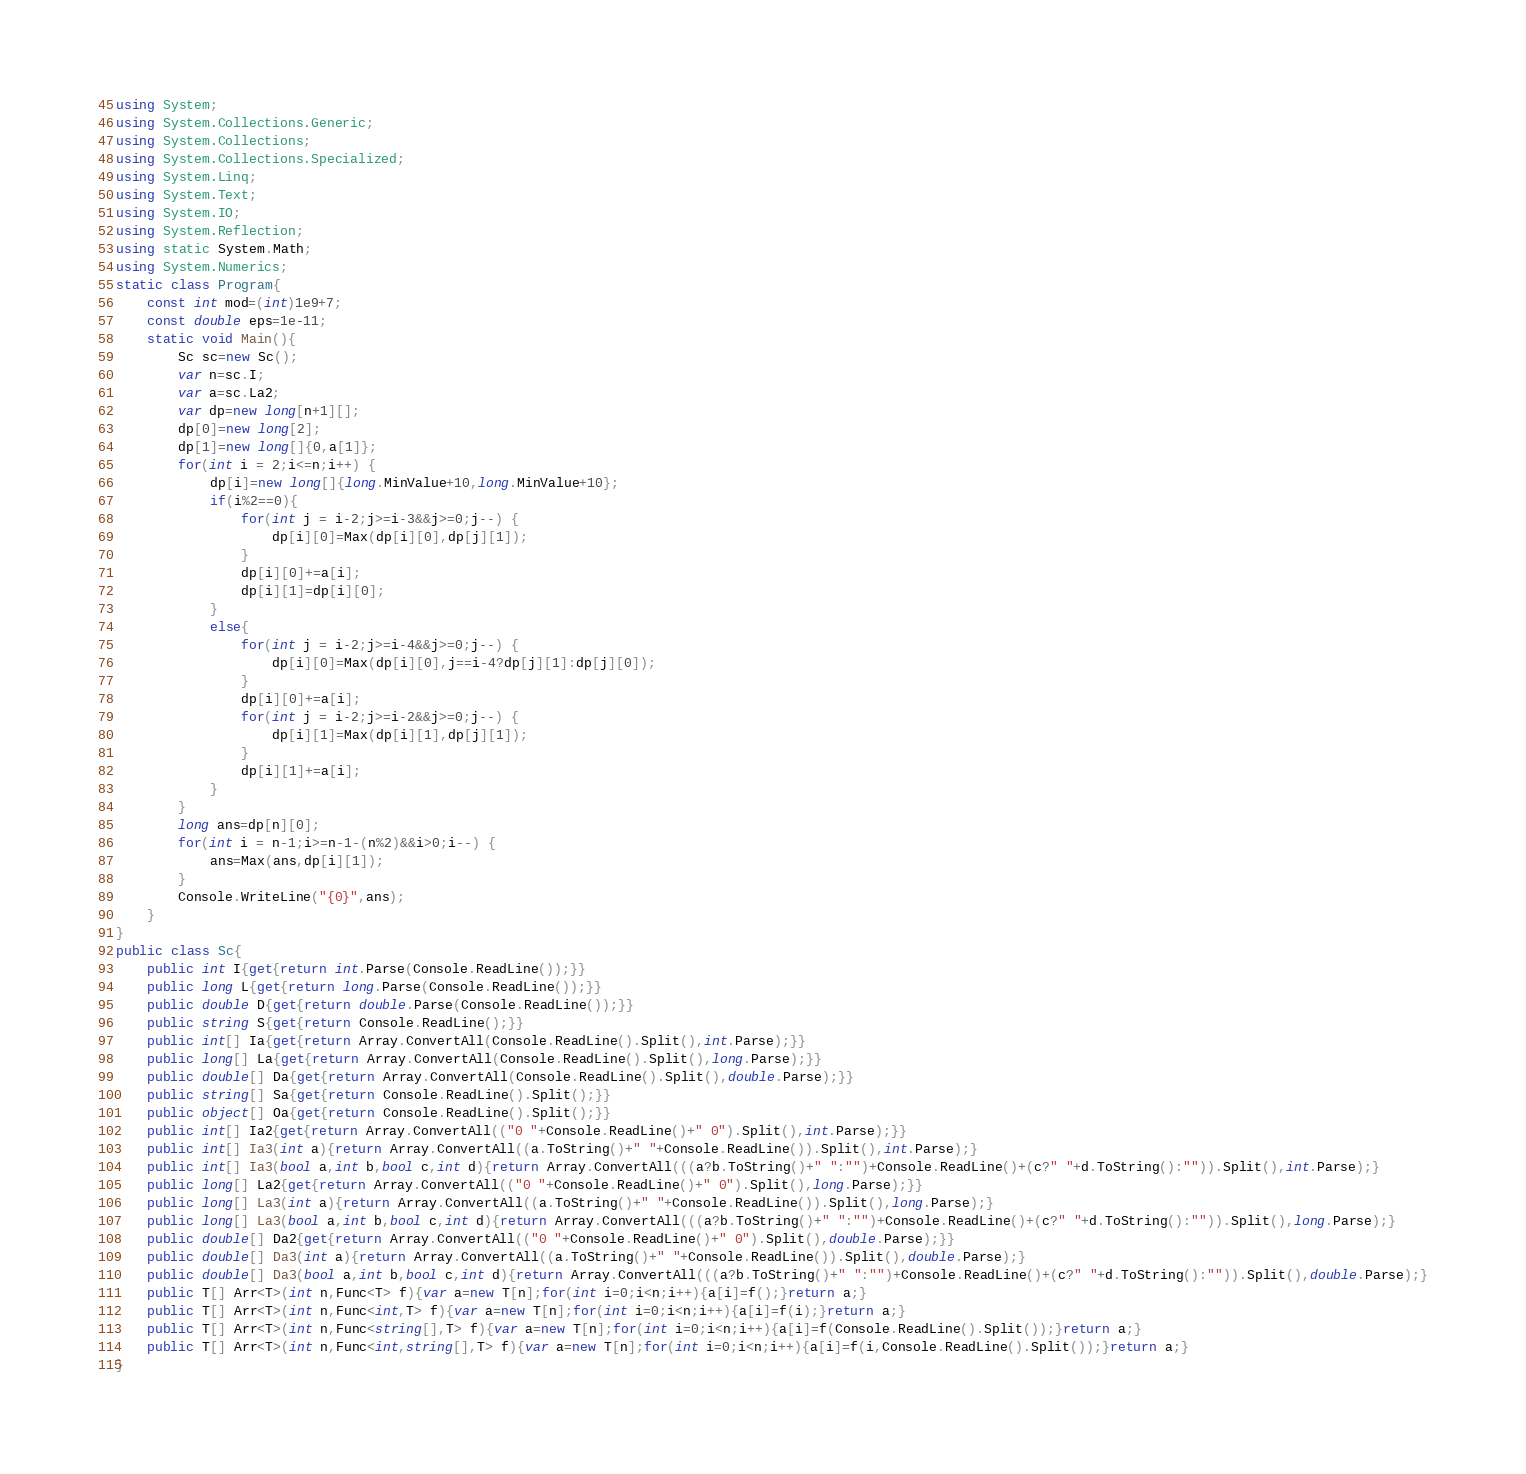Convert code to text. <code><loc_0><loc_0><loc_500><loc_500><_C#_>using System;
using System.Collections.Generic;
using System.Collections;
using System.Collections.Specialized;
using System.Linq;
using System.Text;
using System.IO;
using System.Reflection;
using static System.Math;
using System.Numerics;
static class Program{
	const int mod=(int)1e9+7;
	const double eps=1e-11;
	static void Main(){
		Sc sc=new Sc();
		var n=sc.I;
		var a=sc.La2;
		var dp=new long[n+1][];
		dp[0]=new long[2];
		dp[1]=new long[]{0,a[1]};
		for(int i = 2;i<=n;i++) {
			dp[i]=new long[]{long.MinValue+10,long.MinValue+10};
			if(i%2==0){
				for(int j = i-2;j>=i-3&&j>=0;j--) {
					dp[i][0]=Max(dp[i][0],dp[j][1]);
				}
				dp[i][0]+=a[i];
				dp[i][1]=dp[i][0];
			}
			else{
				for(int j = i-2;j>=i-4&&j>=0;j--) {
					dp[i][0]=Max(dp[i][0],j==i-4?dp[j][1]:dp[j][0]);
				}
				dp[i][0]+=a[i];
				for(int j = i-2;j>=i-2&&j>=0;j--) {
					dp[i][1]=Max(dp[i][1],dp[j][1]);
				}
				dp[i][1]+=a[i];
			}
		}
		long ans=dp[n][0];
		for(int i = n-1;i>=n-1-(n%2)&&i>0;i--) {
			ans=Max(ans,dp[i][1]);
		}
		Console.WriteLine("{0}",ans);
	}
}
public class Sc{
	public int I{get{return int.Parse(Console.ReadLine());}}
	public long L{get{return long.Parse(Console.ReadLine());}}
	public double D{get{return double.Parse(Console.ReadLine());}}
	public string S{get{return Console.ReadLine();}}
	public int[] Ia{get{return Array.ConvertAll(Console.ReadLine().Split(),int.Parse);}}
	public long[] La{get{return Array.ConvertAll(Console.ReadLine().Split(),long.Parse);}}
	public double[] Da{get{return Array.ConvertAll(Console.ReadLine().Split(),double.Parse);}}
	public string[] Sa{get{return Console.ReadLine().Split();}}
	public object[] Oa{get{return Console.ReadLine().Split();}}
	public int[] Ia2{get{return Array.ConvertAll(("0 "+Console.ReadLine()+" 0").Split(),int.Parse);}}
	public int[] Ia3(int a){return Array.ConvertAll((a.ToString()+" "+Console.ReadLine()).Split(),int.Parse);}
	public int[] Ia3(bool a,int b,bool c,int d){return Array.ConvertAll(((a?b.ToString()+" ":"")+Console.ReadLine()+(c?" "+d.ToString():"")).Split(),int.Parse);}
	public long[] La2{get{return Array.ConvertAll(("0 "+Console.ReadLine()+" 0").Split(),long.Parse);}}
	public long[] La3(int a){return Array.ConvertAll((a.ToString()+" "+Console.ReadLine()).Split(),long.Parse);}
	public long[] La3(bool a,int b,bool c,int d){return Array.ConvertAll(((a?b.ToString()+" ":"")+Console.ReadLine()+(c?" "+d.ToString():"")).Split(),long.Parse);}
	public double[] Da2{get{return Array.ConvertAll(("0 "+Console.ReadLine()+" 0").Split(),double.Parse);}}
	public double[] Da3(int a){return Array.ConvertAll((a.ToString()+" "+Console.ReadLine()).Split(),double.Parse);}
	public double[] Da3(bool a,int b,bool c,int d){return Array.ConvertAll(((a?b.ToString()+" ":"")+Console.ReadLine()+(c?" "+d.ToString():"")).Split(),double.Parse);}
	public T[] Arr<T>(int n,Func<T> f){var a=new T[n];for(int i=0;i<n;i++){a[i]=f();}return a;}
	public T[] Arr<T>(int n,Func<int,T> f){var a=new T[n];for(int i=0;i<n;i++){a[i]=f(i);}return a;}
	public T[] Arr<T>(int n,Func<string[],T> f){var a=new T[n];for(int i=0;i<n;i++){a[i]=f(Console.ReadLine().Split());}return a;}
	public T[] Arr<T>(int n,Func<int,string[],T> f){var a=new T[n];for(int i=0;i<n;i++){a[i]=f(i,Console.ReadLine().Split());}return a;}
}</code> 